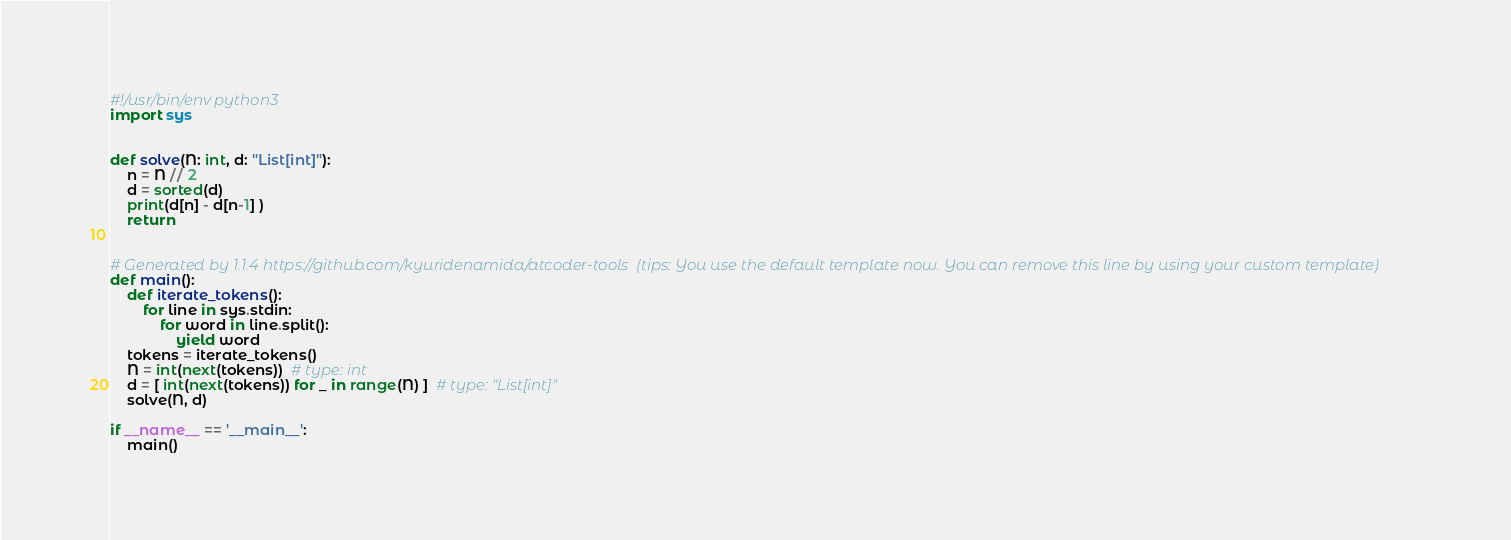Convert code to text. <code><loc_0><loc_0><loc_500><loc_500><_Python_>#!/usr/bin/env python3
import sys


def solve(N: int, d: "List[int]"):
    n = N // 2
    d = sorted(d)
    print(d[n] - d[n-1] )
    return


# Generated by 1.1.4 https://github.com/kyuridenamida/atcoder-tools  (tips: You use the default template now. You can remove this line by using your custom template)
def main():
    def iterate_tokens():
        for line in sys.stdin:
            for word in line.split():
                yield word
    tokens = iterate_tokens()
    N = int(next(tokens))  # type: int
    d = [ int(next(tokens)) for _ in range(N) ]  # type: "List[int]"
    solve(N, d)

if __name__ == '__main__':
    main()
</code> 